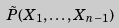Convert formula to latex. <formula><loc_0><loc_0><loc_500><loc_500>\tilde { P } ( X _ { 1 } , \dots , X _ { n - 1 } )</formula> 